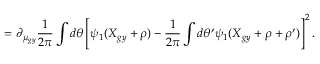<formula> <loc_0><loc_0><loc_500><loc_500>= \partial _ { \mu _ { g y } } \frac { 1 } { 2 \pi } \int d \theta \left [ \psi _ { 1 } ( X _ { g y } + \rho ) - \frac { 1 } { 2 \pi } \int d \theta ^ { \prime } \psi _ { 1 } ( X _ { g y } + \rho + \rho ^ { \prime } ) \right ] ^ { 2 } .</formula> 